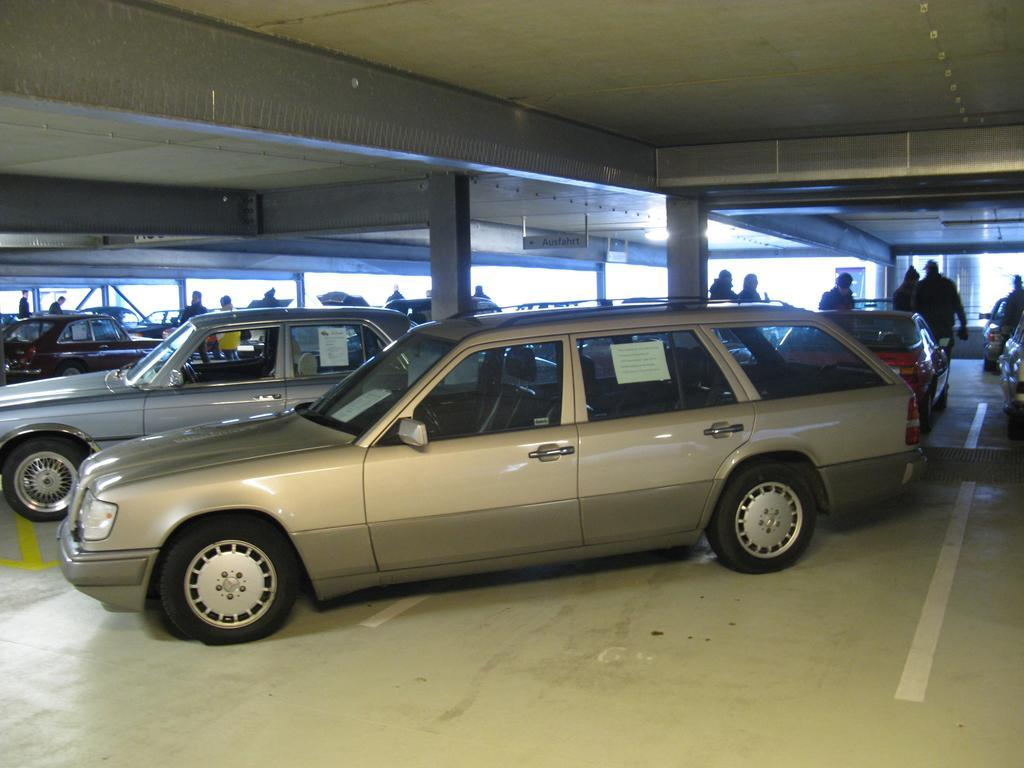What type of vehicles are in the image? There are cars in the image. What other subjects can be seen in the image besides cars? There are people and pillars visible in the image. What degree of difficulty is the person experiencing while climbing the chain in the image? There is no chain present in the image, and therefore no such activity can be observed. How many legs does the car have in the image? Cars do not have legs; they have wheels. 